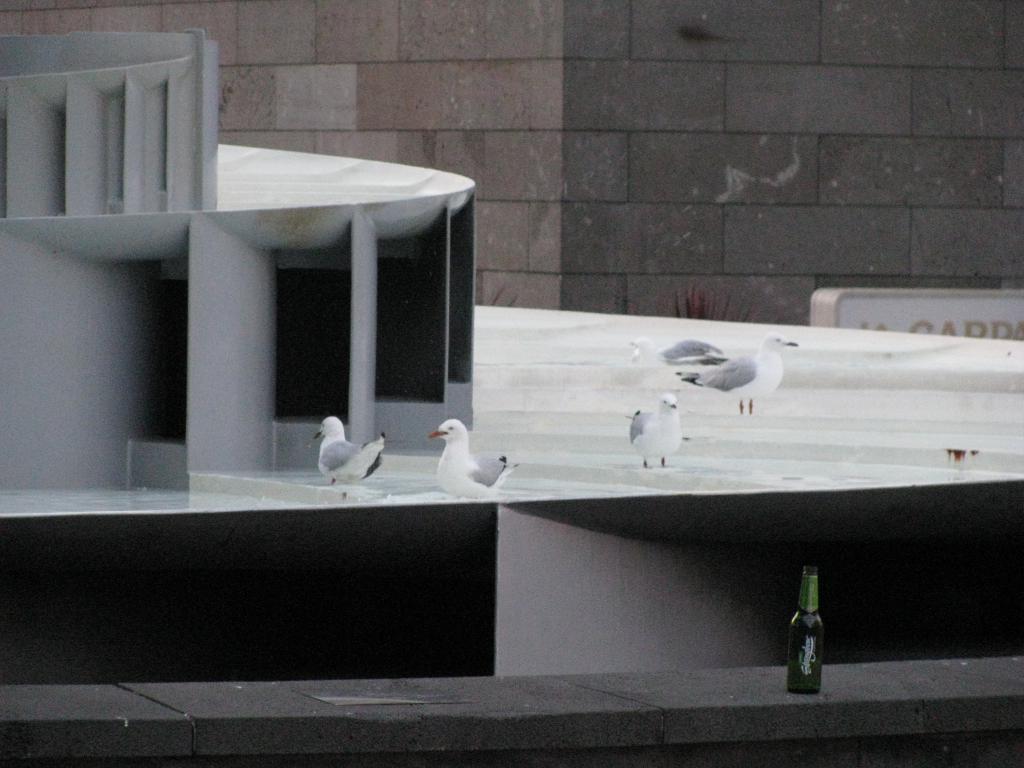In one or two sentences, can you explain what this image depicts? This picture looks like an edited image, in this picture we can see birds, pillars and bottle on the platform. In the background of the image we can see wall and board. 